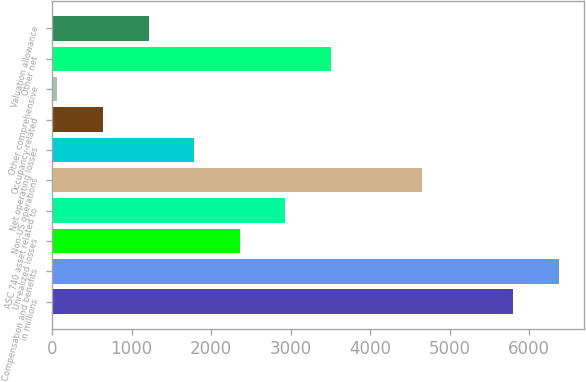Convert chart to OTSL. <chart><loc_0><loc_0><loc_500><loc_500><bar_chart><fcel>in millions<fcel>Compensation and benefits<fcel>Unrealized losses<fcel>ASC 740 asset related to<fcel>Non-US operations<fcel>Net operating losses<fcel>Occupancy-related<fcel>Other comprehensive<fcel>Other net<fcel>Valuation allowance<nl><fcel>5797<fcel>6369.8<fcel>2360.2<fcel>2933<fcel>4651.4<fcel>1787.4<fcel>641.8<fcel>69<fcel>3505.8<fcel>1214.6<nl></chart> 